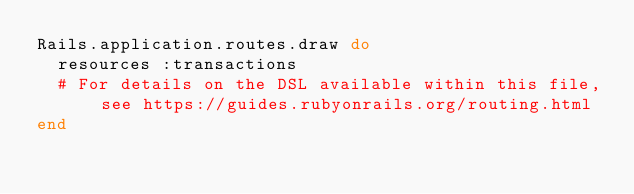Convert code to text. <code><loc_0><loc_0><loc_500><loc_500><_Ruby_>Rails.application.routes.draw do
  resources :transactions
  # For details on the DSL available within this file, see https://guides.rubyonrails.org/routing.html
end
</code> 